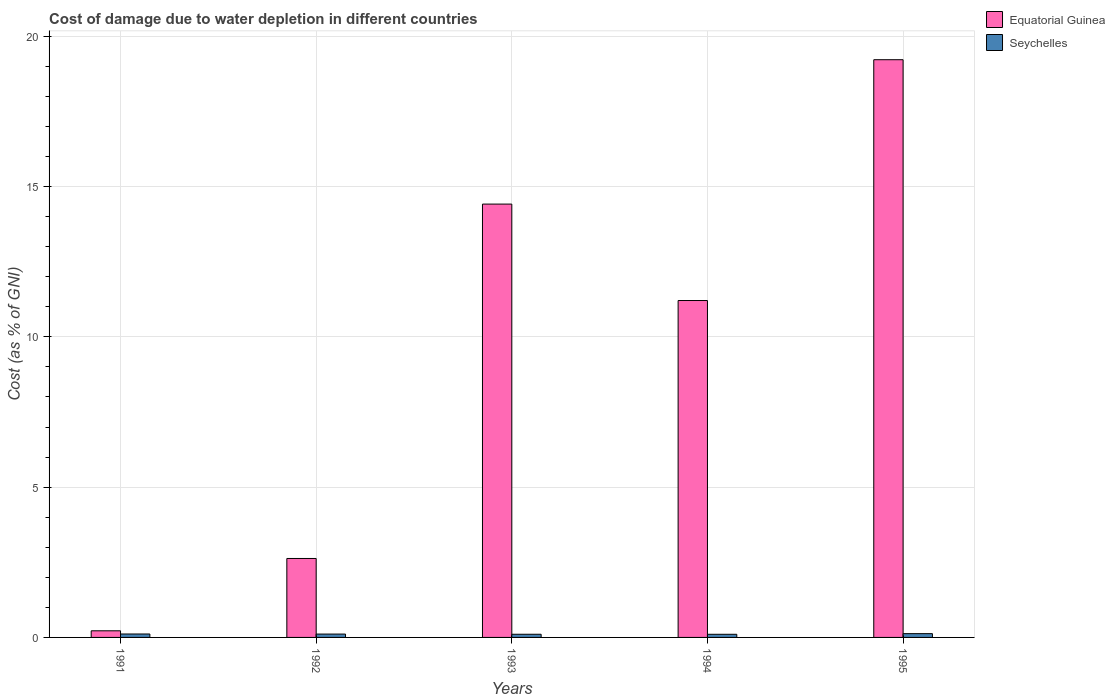How many different coloured bars are there?
Provide a succinct answer. 2. How many bars are there on the 3rd tick from the left?
Your response must be concise. 2. How many bars are there on the 1st tick from the right?
Offer a terse response. 2. What is the cost of damage caused due to water depletion in Seychelles in 1992?
Make the answer very short. 0.11. Across all years, what is the maximum cost of damage caused due to water depletion in Seychelles?
Give a very brief answer. 0.13. Across all years, what is the minimum cost of damage caused due to water depletion in Seychelles?
Your response must be concise. 0.1. In which year was the cost of damage caused due to water depletion in Equatorial Guinea minimum?
Make the answer very short. 1991. What is the total cost of damage caused due to water depletion in Seychelles in the graph?
Keep it short and to the point. 0.56. What is the difference between the cost of damage caused due to water depletion in Equatorial Guinea in 1991 and that in 1995?
Offer a terse response. -19. What is the difference between the cost of damage caused due to water depletion in Equatorial Guinea in 1993 and the cost of damage caused due to water depletion in Seychelles in 1994?
Offer a terse response. 14.31. What is the average cost of damage caused due to water depletion in Equatorial Guinea per year?
Your response must be concise. 9.54. In the year 1992, what is the difference between the cost of damage caused due to water depletion in Equatorial Guinea and cost of damage caused due to water depletion in Seychelles?
Offer a very short reply. 2.51. In how many years, is the cost of damage caused due to water depletion in Equatorial Guinea greater than 13 %?
Make the answer very short. 2. What is the ratio of the cost of damage caused due to water depletion in Seychelles in 1993 to that in 1995?
Give a very brief answer. 0.84. What is the difference between the highest and the second highest cost of damage caused due to water depletion in Seychelles?
Provide a short and direct response. 0.01. What is the difference between the highest and the lowest cost of damage caused due to water depletion in Equatorial Guinea?
Your response must be concise. 19. In how many years, is the cost of damage caused due to water depletion in Seychelles greater than the average cost of damage caused due to water depletion in Seychelles taken over all years?
Give a very brief answer. 2. What does the 1st bar from the left in 1993 represents?
Your answer should be compact. Equatorial Guinea. What does the 1st bar from the right in 1992 represents?
Make the answer very short. Seychelles. How many years are there in the graph?
Keep it short and to the point. 5. What is the difference between two consecutive major ticks on the Y-axis?
Offer a terse response. 5. Are the values on the major ticks of Y-axis written in scientific E-notation?
Give a very brief answer. No. Does the graph contain any zero values?
Keep it short and to the point. No. Does the graph contain grids?
Give a very brief answer. Yes. Where does the legend appear in the graph?
Keep it short and to the point. Top right. What is the title of the graph?
Give a very brief answer. Cost of damage due to water depletion in different countries. Does "Macedonia" appear as one of the legend labels in the graph?
Make the answer very short. No. What is the label or title of the X-axis?
Ensure brevity in your answer.  Years. What is the label or title of the Y-axis?
Provide a succinct answer. Cost (as % of GNI). What is the Cost (as % of GNI) in Equatorial Guinea in 1991?
Provide a succinct answer. 0.22. What is the Cost (as % of GNI) in Seychelles in 1991?
Ensure brevity in your answer.  0.11. What is the Cost (as % of GNI) in Equatorial Guinea in 1992?
Provide a short and direct response. 2.63. What is the Cost (as % of GNI) of Seychelles in 1992?
Offer a very short reply. 0.11. What is the Cost (as % of GNI) of Equatorial Guinea in 1993?
Your answer should be very brief. 14.42. What is the Cost (as % of GNI) of Seychelles in 1993?
Your answer should be compact. 0.11. What is the Cost (as % of GNI) of Equatorial Guinea in 1994?
Your answer should be very brief. 11.21. What is the Cost (as % of GNI) of Seychelles in 1994?
Offer a terse response. 0.1. What is the Cost (as % of GNI) of Equatorial Guinea in 1995?
Your answer should be compact. 19.22. What is the Cost (as % of GNI) in Seychelles in 1995?
Your response must be concise. 0.13. Across all years, what is the maximum Cost (as % of GNI) in Equatorial Guinea?
Give a very brief answer. 19.22. Across all years, what is the maximum Cost (as % of GNI) in Seychelles?
Keep it short and to the point. 0.13. Across all years, what is the minimum Cost (as % of GNI) in Equatorial Guinea?
Provide a succinct answer. 0.22. Across all years, what is the minimum Cost (as % of GNI) of Seychelles?
Give a very brief answer. 0.1. What is the total Cost (as % of GNI) in Equatorial Guinea in the graph?
Offer a terse response. 47.69. What is the total Cost (as % of GNI) in Seychelles in the graph?
Keep it short and to the point. 0.56. What is the difference between the Cost (as % of GNI) in Equatorial Guinea in 1991 and that in 1992?
Your response must be concise. -2.41. What is the difference between the Cost (as % of GNI) of Seychelles in 1991 and that in 1992?
Provide a succinct answer. 0. What is the difference between the Cost (as % of GNI) in Equatorial Guinea in 1991 and that in 1993?
Offer a very short reply. -14.2. What is the difference between the Cost (as % of GNI) of Seychelles in 1991 and that in 1993?
Ensure brevity in your answer.  0.01. What is the difference between the Cost (as % of GNI) in Equatorial Guinea in 1991 and that in 1994?
Keep it short and to the point. -10.99. What is the difference between the Cost (as % of GNI) in Seychelles in 1991 and that in 1994?
Make the answer very short. 0.01. What is the difference between the Cost (as % of GNI) in Equatorial Guinea in 1991 and that in 1995?
Give a very brief answer. -19. What is the difference between the Cost (as % of GNI) in Seychelles in 1991 and that in 1995?
Provide a short and direct response. -0.01. What is the difference between the Cost (as % of GNI) in Equatorial Guinea in 1992 and that in 1993?
Keep it short and to the point. -11.79. What is the difference between the Cost (as % of GNI) in Seychelles in 1992 and that in 1993?
Keep it short and to the point. 0.01. What is the difference between the Cost (as % of GNI) of Equatorial Guinea in 1992 and that in 1994?
Provide a short and direct response. -8.58. What is the difference between the Cost (as % of GNI) of Seychelles in 1992 and that in 1994?
Your answer should be very brief. 0.01. What is the difference between the Cost (as % of GNI) of Equatorial Guinea in 1992 and that in 1995?
Your answer should be compact. -16.59. What is the difference between the Cost (as % of GNI) of Seychelles in 1992 and that in 1995?
Provide a succinct answer. -0.01. What is the difference between the Cost (as % of GNI) in Equatorial Guinea in 1993 and that in 1994?
Offer a very short reply. 3.21. What is the difference between the Cost (as % of GNI) of Seychelles in 1993 and that in 1994?
Your answer should be very brief. 0. What is the difference between the Cost (as % of GNI) of Equatorial Guinea in 1993 and that in 1995?
Offer a terse response. -4.8. What is the difference between the Cost (as % of GNI) in Seychelles in 1993 and that in 1995?
Ensure brevity in your answer.  -0.02. What is the difference between the Cost (as % of GNI) of Equatorial Guinea in 1994 and that in 1995?
Keep it short and to the point. -8.01. What is the difference between the Cost (as % of GNI) in Seychelles in 1994 and that in 1995?
Make the answer very short. -0.02. What is the difference between the Cost (as % of GNI) of Equatorial Guinea in 1991 and the Cost (as % of GNI) of Seychelles in 1992?
Give a very brief answer. 0.11. What is the difference between the Cost (as % of GNI) in Equatorial Guinea in 1991 and the Cost (as % of GNI) in Seychelles in 1993?
Ensure brevity in your answer.  0.12. What is the difference between the Cost (as % of GNI) of Equatorial Guinea in 1991 and the Cost (as % of GNI) of Seychelles in 1994?
Your answer should be very brief. 0.12. What is the difference between the Cost (as % of GNI) in Equatorial Guinea in 1991 and the Cost (as % of GNI) in Seychelles in 1995?
Your answer should be very brief. 0.09. What is the difference between the Cost (as % of GNI) in Equatorial Guinea in 1992 and the Cost (as % of GNI) in Seychelles in 1993?
Provide a succinct answer. 2.52. What is the difference between the Cost (as % of GNI) in Equatorial Guinea in 1992 and the Cost (as % of GNI) in Seychelles in 1994?
Keep it short and to the point. 2.52. What is the difference between the Cost (as % of GNI) in Equatorial Guinea in 1992 and the Cost (as % of GNI) in Seychelles in 1995?
Provide a succinct answer. 2.5. What is the difference between the Cost (as % of GNI) in Equatorial Guinea in 1993 and the Cost (as % of GNI) in Seychelles in 1994?
Provide a short and direct response. 14.31. What is the difference between the Cost (as % of GNI) of Equatorial Guinea in 1993 and the Cost (as % of GNI) of Seychelles in 1995?
Your answer should be compact. 14.29. What is the difference between the Cost (as % of GNI) in Equatorial Guinea in 1994 and the Cost (as % of GNI) in Seychelles in 1995?
Provide a succinct answer. 11.08. What is the average Cost (as % of GNI) in Equatorial Guinea per year?
Give a very brief answer. 9.54. What is the average Cost (as % of GNI) of Seychelles per year?
Offer a very short reply. 0.11. In the year 1991, what is the difference between the Cost (as % of GNI) of Equatorial Guinea and Cost (as % of GNI) of Seychelles?
Give a very brief answer. 0.11. In the year 1992, what is the difference between the Cost (as % of GNI) of Equatorial Guinea and Cost (as % of GNI) of Seychelles?
Provide a succinct answer. 2.51. In the year 1993, what is the difference between the Cost (as % of GNI) of Equatorial Guinea and Cost (as % of GNI) of Seychelles?
Give a very brief answer. 14.31. In the year 1994, what is the difference between the Cost (as % of GNI) in Equatorial Guinea and Cost (as % of GNI) in Seychelles?
Provide a short and direct response. 11.1. In the year 1995, what is the difference between the Cost (as % of GNI) of Equatorial Guinea and Cost (as % of GNI) of Seychelles?
Give a very brief answer. 19.09. What is the ratio of the Cost (as % of GNI) in Equatorial Guinea in 1991 to that in 1992?
Provide a succinct answer. 0.08. What is the ratio of the Cost (as % of GNI) in Equatorial Guinea in 1991 to that in 1993?
Ensure brevity in your answer.  0.02. What is the ratio of the Cost (as % of GNI) in Seychelles in 1991 to that in 1993?
Provide a succinct answer. 1.09. What is the ratio of the Cost (as % of GNI) of Equatorial Guinea in 1991 to that in 1994?
Provide a succinct answer. 0.02. What is the ratio of the Cost (as % of GNI) of Seychelles in 1991 to that in 1994?
Your answer should be very brief. 1.09. What is the ratio of the Cost (as % of GNI) of Equatorial Guinea in 1991 to that in 1995?
Your response must be concise. 0.01. What is the ratio of the Cost (as % of GNI) of Seychelles in 1991 to that in 1995?
Your answer should be compact. 0.91. What is the ratio of the Cost (as % of GNI) in Equatorial Guinea in 1992 to that in 1993?
Your response must be concise. 0.18. What is the ratio of the Cost (as % of GNI) in Seychelles in 1992 to that in 1993?
Offer a terse response. 1.06. What is the ratio of the Cost (as % of GNI) in Equatorial Guinea in 1992 to that in 1994?
Offer a terse response. 0.23. What is the ratio of the Cost (as % of GNI) of Seychelles in 1992 to that in 1994?
Give a very brief answer. 1.07. What is the ratio of the Cost (as % of GNI) of Equatorial Guinea in 1992 to that in 1995?
Keep it short and to the point. 0.14. What is the ratio of the Cost (as % of GNI) of Seychelles in 1992 to that in 1995?
Your answer should be very brief. 0.89. What is the ratio of the Cost (as % of GNI) in Equatorial Guinea in 1993 to that in 1994?
Your response must be concise. 1.29. What is the ratio of the Cost (as % of GNI) of Seychelles in 1993 to that in 1994?
Your answer should be compact. 1.01. What is the ratio of the Cost (as % of GNI) of Equatorial Guinea in 1993 to that in 1995?
Your answer should be compact. 0.75. What is the ratio of the Cost (as % of GNI) in Seychelles in 1993 to that in 1995?
Offer a terse response. 0.84. What is the ratio of the Cost (as % of GNI) of Equatorial Guinea in 1994 to that in 1995?
Your answer should be compact. 0.58. What is the ratio of the Cost (as % of GNI) of Seychelles in 1994 to that in 1995?
Your answer should be compact. 0.83. What is the difference between the highest and the second highest Cost (as % of GNI) in Equatorial Guinea?
Offer a terse response. 4.8. What is the difference between the highest and the second highest Cost (as % of GNI) in Seychelles?
Offer a terse response. 0.01. What is the difference between the highest and the lowest Cost (as % of GNI) in Equatorial Guinea?
Make the answer very short. 19. What is the difference between the highest and the lowest Cost (as % of GNI) in Seychelles?
Give a very brief answer. 0.02. 